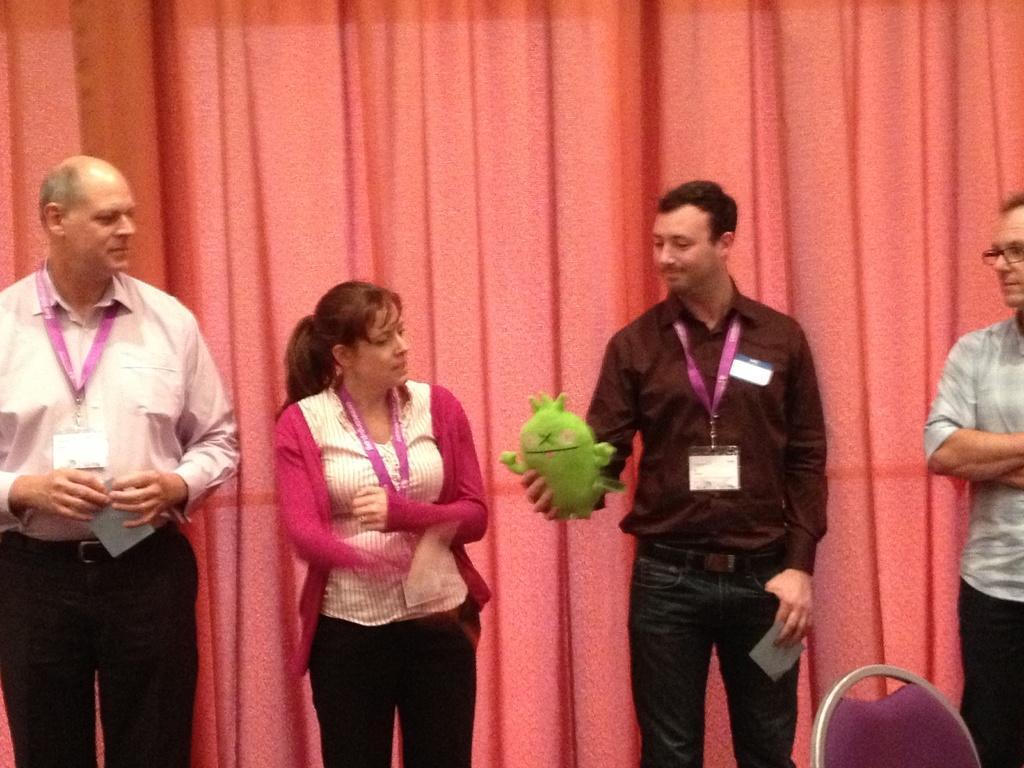Can you describe this image briefly? In the picture we can see a four people standing three men and a woman, they are wearing a tag with ID cards and in the background, we can see a curtain and inside of them we can see a chair. 